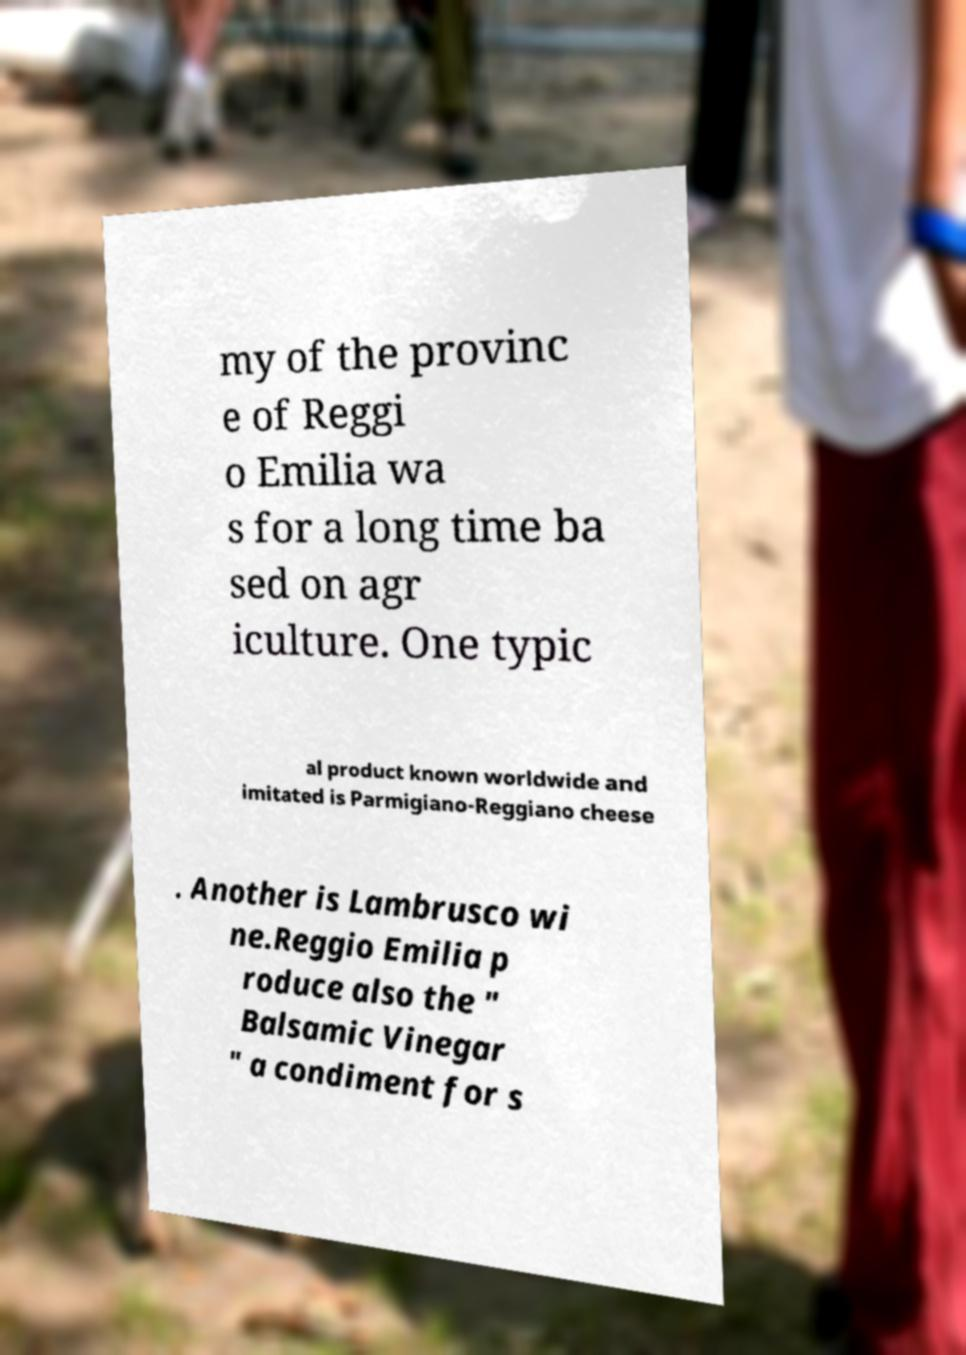What messages or text are displayed in this image? I need them in a readable, typed format. my of the provinc e of Reggi o Emilia wa s for a long time ba sed on agr iculture. One typic al product known worldwide and imitated is Parmigiano-Reggiano cheese . Another is Lambrusco wi ne.Reggio Emilia p roduce also the " Balsamic Vinegar " a condiment for s 